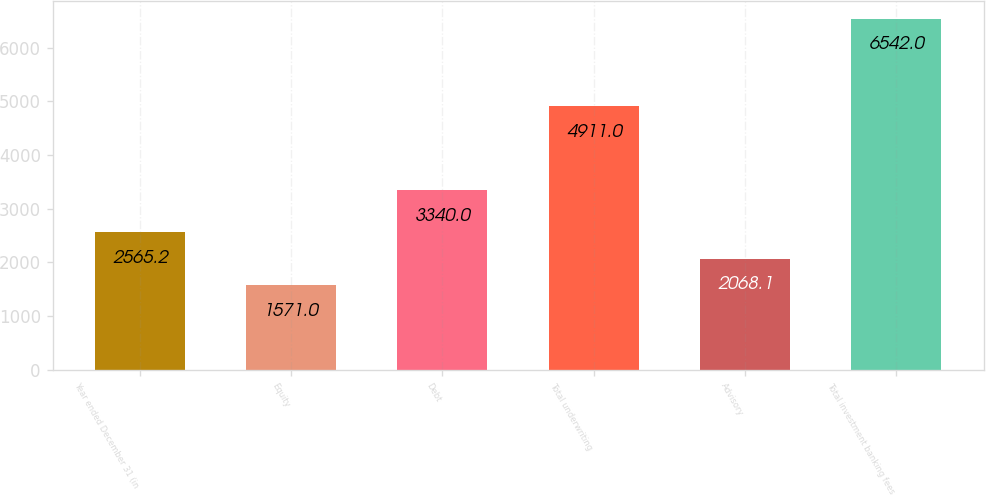<chart> <loc_0><loc_0><loc_500><loc_500><bar_chart><fcel>Year ended December 31 (in<fcel>Equity<fcel>Debt<fcel>Total underwriting<fcel>Advisory<fcel>Total investment banking fees<nl><fcel>2565.2<fcel>1571<fcel>3340<fcel>4911<fcel>2068.1<fcel>6542<nl></chart> 